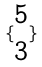Convert formula to latex. <formula><loc_0><loc_0><loc_500><loc_500>\{ \begin{matrix} 5 \\ 3 \end{matrix} \}</formula> 